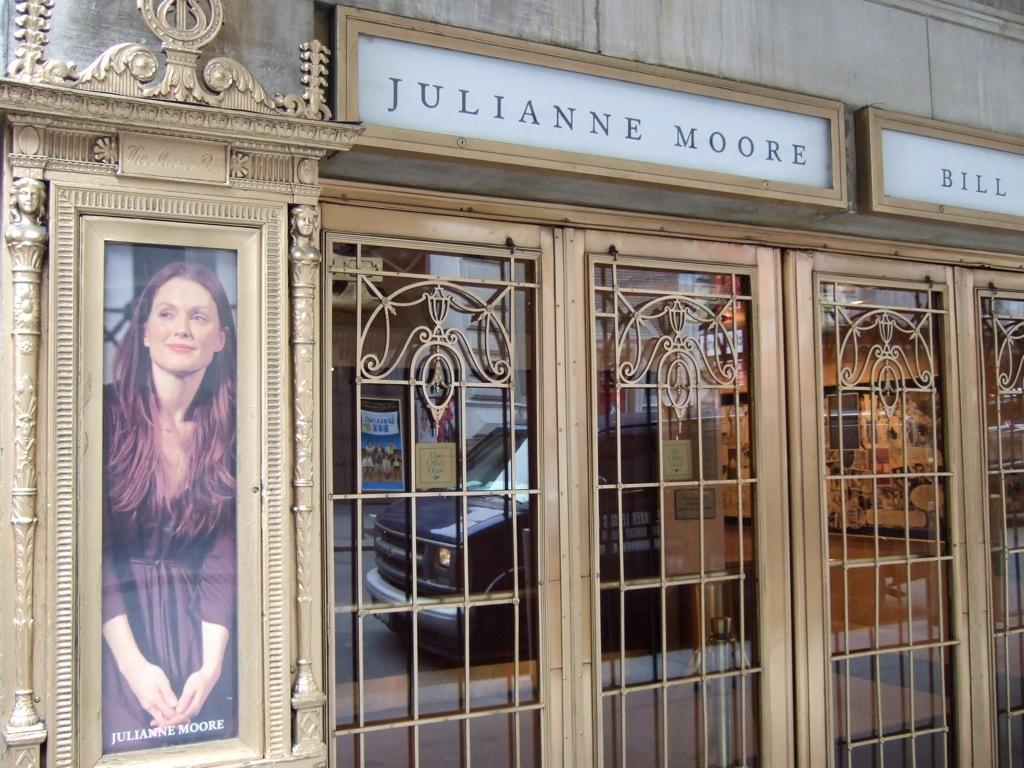Provide a one-sentence caption for the provided image. Julianne moore sign above a building including her picture on the left side. 